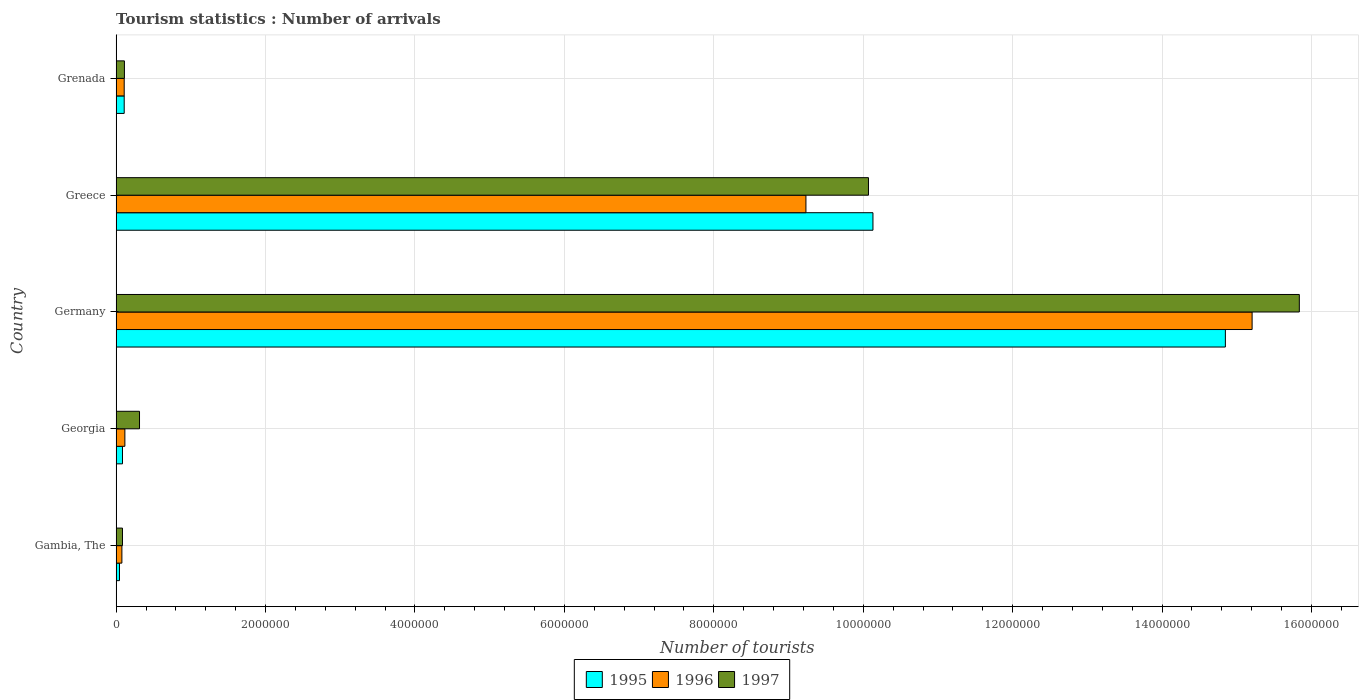How many different coloured bars are there?
Keep it short and to the point. 3. How many groups of bars are there?
Ensure brevity in your answer.  5. Are the number of bars per tick equal to the number of legend labels?
Give a very brief answer. Yes. Are the number of bars on each tick of the Y-axis equal?
Your answer should be very brief. Yes. How many bars are there on the 3rd tick from the bottom?
Provide a succinct answer. 3. What is the label of the 5th group of bars from the top?
Your answer should be compact. Gambia, The. What is the number of tourist arrivals in 1996 in Gambia, The?
Your response must be concise. 7.70e+04. Across all countries, what is the maximum number of tourist arrivals in 1996?
Offer a very short reply. 1.52e+07. Across all countries, what is the minimum number of tourist arrivals in 1995?
Your response must be concise. 4.50e+04. In which country was the number of tourist arrivals in 1996 minimum?
Your answer should be very brief. Gambia, The. What is the total number of tourist arrivals in 1996 in the graph?
Keep it short and to the point. 2.47e+07. What is the difference between the number of tourist arrivals in 1996 in Greece and that in Grenada?
Give a very brief answer. 9.12e+06. What is the difference between the number of tourist arrivals in 1995 in Greece and the number of tourist arrivals in 1996 in Georgia?
Your answer should be compact. 1.00e+07. What is the average number of tourist arrivals in 1997 per country?
Your response must be concise. 5.28e+06. What is the difference between the number of tourist arrivals in 1995 and number of tourist arrivals in 1996 in Georgia?
Keep it short and to the point. -3.20e+04. What is the ratio of the number of tourist arrivals in 1997 in Germany to that in Greece?
Provide a short and direct response. 1.57. What is the difference between the highest and the second highest number of tourist arrivals in 1996?
Your answer should be very brief. 5.97e+06. What is the difference between the highest and the lowest number of tourist arrivals in 1997?
Your answer should be very brief. 1.58e+07. Is the sum of the number of tourist arrivals in 1997 in Germany and Greece greater than the maximum number of tourist arrivals in 1996 across all countries?
Provide a succinct answer. Yes. What does the 1st bar from the top in Georgia represents?
Give a very brief answer. 1997. What does the 3rd bar from the bottom in Greece represents?
Offer a very short reply. 1997. Is it the case that in every country, the sum of the number of tourist arrivals in 1997 and number of tourist arrivals in 1996 is greater than the number of tourist arrivals in 1995?
Your response must be concise. Yes. How many countries are there in the graph?
Offer a terse response. 5. What is the difference between two consecutive major ticks on the X-axis?
Make the answer very short. 2.00e+06. Are the values on the major ticks of X-axis written in scientific E-notation?
Your answer should be very brief. No. Does the graph contain any zero values?
Give a very brief answer. No. Where does the legend appear in the graph?
Keep it short and to the point. Bottom center. What is the title of the graph?
Your response must be concise. Tourism statistics : Number of arrivals. Does "2000" appear as one of the legend labels in the graph?
Your response must be concise. No. What is the label or title of the X-axis?
Provide a short and direct response. Number of tourists. What is the label or title of the Y-axis?
Your answer should be very brief. Country. What is the Number of tourists in 1995 in Gambia, The?
Your response must be concise. 4.50e+04. What is the Number of tourists of 1996 in Gambia, The?
Offer a very short reply. 7.70e+04. What is the Number of tourists in 1997 in Gambia, The?
Provide a short and direct response. 8.50e+04. What is the Number of tourists in 1995 in Georgia?
Your response must be concise. 8.50e+04. What is the Number of tourists in 1996 in Georgia?
Give a very brief answer. 1.17e+05. What is the Number of tourists in 1997 in Georgia?
Your answer should be compact. 3.13e+05. What is the Number of tourists of 1995 in Germany?
Your answer should be compact. 1.48e+07. What is the Number of tourists of 1996 in Germany?
Make the answer very short. 1.52e+07. What is the Number of tourists in 1997 in Germany?
Provide a succinct answer. 1.58e+07. What is the Number of tourists in 1995 in Greece?
Give a very brief answer. 1.01e+07. What is the Number of tourists of 1996 in Greece?
Make the answer very short. 9.23e+06. What is the Number of tourists of 1997 in Greece?
Provide a short and direct response. 1.01e+07. What is the Number of tourists of 1995 in Grenada?
Make the answer very short. 1.08e+05. What is the Number of tourists of 1996 in Grenada?
Ensure brevity in your answer.  1.08e+05. What is the Number of tourists in 1997 in Grenada?
Keep it short and to the point. 1.11e+05. Across all countries, what is the maximum Number of tourists in 1995?
Your response must be concise. 1.48e+07. Across all countries, what is the maximum Number of tourists in 1996?
Offer a terse response. 1.52e+07. Across all countries, what is the maximum Number of tourists of 1997?
Your answer should be compact. 1.58e+07. Across all countries, what is the minimum Number of tourists in 1995?
Your answer should be compact. 4.50e+04. Across all countries, what is the minimum Number of tourists in 1996?
Give a very brief answer. 7.70e+04. Across all countries, what is the minimum Number of tourists in 1997?
Keep it short and to the point. 8.50e+04. What is the total Number of tourists of 1995 in the graph?
Offer a very short reply. 2.52e+07. What is the total Number of tourists in 1996 in the graph?
Provide a short and direct response. 2.47e+07. What is the total Number of tourists in 1997 in the graph?
Your answer should be compact. 2.64e+07. What is the difference between the Number of tourists in 1995 in Gambia, The and that in Georgia?
Provide a succinct answer. -4.00e+04. What is the difference between the Number of tourists of 1997 in Gambia, The and that in Georgia?
Offer a terse response. -2.28e+05. What is the difference between the Number of tourists in 1995 in Gambia, The and that in Germany?
Provide a succinct answer. -1.48e+07. What is the difference between the Number of tourists of 1996 in Gambia, The and that in Germany?
Ensure brevity in your answer.  -1.51e+07. What is the difference between the Number of tourists in 1997 in Gambia, The and that in Germany?
Your answer should be compact. -1.58e+07. What is the difference between the Number of tourists of 1995 in Gambia, The and that in Greece?
Your answer should be compact. -1.01e+07. What is the difference between the Number of tourists of 1996 in Gambia, The and that in Greece?
Make the answer very short. -9.16e+06. What is the difference between the Number of tourists of 1997 in Gambia, The and that in Greece?
Provide a short and direct response. -9.98e+06. What is the difference between the Number of tourists in 1995 in Gambia, The and that in Grenada?
Your answer should be very brief. -6.30e+04. What is the difference between the Number of tourists in 1996 in Gambia, The and that in Grenada?
Provide a short and direct response. -3.10e+04. What is the difference between the Number of tourists in 1997 in Gambia, The and that in Grenada?
Ensure brevity in your answer.  -2.60e+04. What is the difference between the Number of tourists in 1995 in Georgia and that in Germany?
Offer a very short reply. -1.48e+07. What is the difference between the Number of tourists in 1996 in Georgia and that in Germany?
Your answer should be compact. -1.51e+07. What is the difference between the Number of tourists of 1997 in Georgia and that in Germany?
Offer a terse response. -1.55e+07. What is the difference between the Number of tourists of 1995 in Georgia and that in Greece?
Keep it short and to the point. -1.00e+07. What is the difference between the Number of tourists of 1996 in Georgia and that in Greece?
Offer a very short reply. -9.12e+06. What is the difference between the Number of tourists in 1997 in Georgia and that in Greece?
Your answer should be compact. -9.76e+06. What is the difference between the Number of tourists of 1995 in Georgia and that in Grenada?
Make the answer very short. -2.30e+04. What is the difference between the Number of tourists in 1996 in Georgia and that in Grenada?
Offer a terse response. 9000. What is the difference between the Number of tourists of 1997 in Georgia and that in Grenada?
Provide a short and direct response. 2.02e+05. What is the difference between the Number of tourists in 1995 in Germany and that in Greece?
Your answer should be compact. 4.72e+06. What is the difference between the Number of tourists in 1996 in Germany and that in Greece?
Your answer should be compact. 5.97e+06. What is the difference between the Number of tourists of 1997 in Germany and that in Greece?
Ensure brevity in your answer.  5.77e+06. What is the difference between the Number of tourists of 1995 in Germany and that in Grenada?
Give a very brief answer. 1.47e+07. What is the difference between the Number of tourists in 1996 in Germany and that in Grenada?
Provide a short and direct response. 1.51e+07. What is the difference between the Number of tourists in 1997 in Germany and that in Grenada?
Offer a very short reply. 1.57e+07. What is the difference between the Number of tourists in 1995 in Greece and that in Grenada?
Your answer should be very brief. 1.00e+07. What is the difference between the Number of tourists in 1996 in Greece and that in Grenada?
Provide a succinct answer. 9.12e+06. What is the difference between the Number of tourists in 1997 in Greece and that in Grenada?
Offer a terse response. 9.96e+06. What is the difference between the Number of tourists of 1995 in Gambia, The and the Number of tourists of 1996 in Georgia?
Offer a very short reply. -7.20e+04. What is the difference between the Number of tourists in 1995 in Gambia, The and the Number of tourists in 1997 in Georgia?
Give a very brief answer. -2.68e+05. What is the difference between the Number of tourists in 1996 in Gambia, The and the Number of tourists in 1997 in Georgia?
Keep it short and to the point. -2.36e+05. What is the difference between the Number of tourists of 1995 in Gambia, The and the Number of tourists of 1996 in Germany?
Provide a short and direct response. -1.52e+07. What is the difference between the Number of tourists in 1995 in Gambia, The and the Number of tourists in 1997 in Germany?
Give a very brief answer. -1.58e+07. What is the difference between the Number of tourists in 1996 in Gambia, The and the Number of tourists in 1997 in Germany?
Offer a very short reply. -1.58e+07. What is the difference between the Number of tourists of 1995 in Gambia, The and the Number of tourists of 1996 in Greece?
Provide a short and direct response. -9.19e+06. What is the difference between the Number of tourists in 1995 in Gambia, The and the Number of tourists in 1997 in Greece?
Your response must be concise. -1.00e+07. What is the difference between the Number of tourists of 1996 in Gambia, The and the Number of tourists of 1997 in Greece?
Your answer should be very brief. -9.99e+06. What is the difference between the Number of tourists of 1995 in Gambia, The and the Number of tourists of 1996 in Grenada?
Ensure brevity in your answer.  -6.30e+04. What is the difference between the Number of tourists in 1995 in Gambia, The and the Number of tourists in 1997 in Grenada?
Ensure brevity in your answer.  -6.60e+04. What is the difference between the Number of tourists of 1996 in Gambia, The and the Number of tourists of 1997 in Grenada?
Offer a terse response. -3.40e+04. What is the difference between the Number of tourists in 1995 in Georgia and the Number of tourists in 1996 in Germany?
Provide a short and direct response. -1.51e+07. What is the difference between the Number of tourists of 1995 in Georgia and the Number of tourists of 1997 in Germany?
Offer a very short reply. -1.58e+07. What is the difference between the Number of tourists of 1996 in Georgia and the Number of tourists of 1997 in Germany?
Give a very brief answer. -1.57e+07. What is the difference between the Number of tourists in 1995 in Georgia and the Number of tourists in 1996 in Greece?
Your answer should be compact. -9.15e+06. What is the difference between the Number of tourists in 1995 in Georgia and the Number of tourists in 1997 in Greece?
Give a very brief answer. -9.98e+06. What is the difference between the Number of tourists of 1996 in Georgia and the Number of tourists of 1997 in Greece?
Make the answer very short. -9.95e+06. What is the difference between the Number of tourists of 1995 in Georgia and the Number of tourists of 1996 in Grenada?
Offer a terse response. -2.30e+04. What is the difference between the Number of tourists in 1995 in Georgia and the Number of tourists in 1997 in Grenada?
Give a very brief answer. -2.60e+04. What is the difference between the Number of tourists in 1996 in Georgia and the Number of tourists in 1997 in Grenada?
Provide a succinct answer. 6000. What is the difference between the Number of tourists in 1995 in Germany and the Number of tourists in 1996 in Greece?
Offer a terse response. 5.61e+06. What is the difference between the Number of tourists of 1995 in Germany and the Number of tourists of 1997 in Greece?
Keep it short and to the point. 4.78e+06. What is the difference between the Number of tourists of 1996 in Germany and the Number of tourists of 1997 in Greece?
Your answer should be very brief. 5.14e+06. What is the difference between the Number of tourists in 1995 in Germany and the Number of tourists in 1996 in Grenada?
Your answer should be compact. 1.47e+07. What is the difference between the Number of tourists in 1995 in Germany and the Number of tourists in 1997 in Grenada?
Make the answer very short. 1.47e+07. What is the difference between the Number of tourists in 1996 in Germany and the Number of tourists in 1997 in Grenada?
Provide a short and direct response. 1.51e+07. What is the difference between the Number of tourists of 1995 in Greece and the Number of tourists of 1996 in Grenada?
Give a very brief answer. 1.00e+07. What is the difference between the Number of tourists of 1995 in Greece and the Number of tourists of 1997 in Grenada?
Your answer should be compact. 1.00e+07. What is the difference between the Number of tourists in 1996 in Greece and the Number of tourists in 1997 in Grenada?
Make the answer very short. 9.12e+06. What is the average Number of tourists of 1995 per country?
Your response must be concise. 5.04e+06. What is the average Number of tourists of 1996 per country?
Your answer should be compact. 4.95e+06. What is the average Number of tourists of 1997 per country?
Make the answer very short. 5.28e+06. What is the difference between the Number of tourists in 1995 and Number of tourists in 1996 in Gambia, The?
Your answer should be very brief. -3.20e+04. What is the difference between the Number of tourists in 1996 and Number of tourists in 1997 in Gambia, The?
Your answer should be very brief. -8000. What is the difference between the Number of tourists in 1995 and Number of tourists in 1996 in Georgia?
Your response must be concise. -3.20e+04. What is the difference between the Number of tourists of 1995 and Number of tourists of 1997 in Georgia?
Offer a very short reply. -2.28e+05. What is the difference between the Number of tourists in 1996 and Number of tourists in 1997 in Georgia?
Give a very brief answer. -1.96e+05. What is the difference between the Number of tourists of 1995 and Number of tourists of 1996 in Germany?
Keep it short and to the point. -3.58e+05. What is the difference between the Number of tourists of 1995 and Number of tourists of 1997 in Germany?
Keep it short and to the point. -9.90e+05. What is the difference between the Number of tourists of 1996 and Number of tourists of 1997 in Germany?
Make the answer very short. -6.32e+05. What is the difference between the Number of tourists in 1995 and Number of tourists in 1996 in Greece?
Your response must be concise. 8.97e+05. What is the difference between the Number of tourists in 1995 and Number of tourists in 1997 in Greece?
Give a very brief answer. 6.00e+04. What is the difference between the Number of tourists in 1996 and Number of tourists in 1997 in Greece?
Your answer should be compact. -8.37e+05. What is the difference between the Number of tourists of 1995 and Number of tourists of 1997 in Grenada?
Provide a short and direct response. -3000. What is the difference between the Number of tourists of 1996 and Number of tourists of 1997 in Grenada?
Offer a terse response. -3000. What is the ratio of the Number of tourists of 1995 in Gambia, The to that in Georgia?
Offer a terse response. 0.53. What is the ratio of the Number of tourists in 1996 in Gambia, The to that in Georgia?
Give a very brief answer. 0.66. What is the ratio of the Number of tourists of 1997 in Gambia, The to that in Georgia?
Your response must be concise. 0.27. What is the ratio of the Number of tourists of 1995 in Gambia, The to that in Germany?
Your response must be concise. 0. What is the ratio of the Number of tourists of 1996 in Gambia, The to that in Germany?
Make the answer very short. 0.01. What is the ratio of the Number of tourists of 1997 in Gambia, The to that in Germany?
Provide a short and direct response. 0.01. What is the ratio of the Number of tourists in 1995 in Gambia, The to that in Greece?
Your answer should be very brief. 0. What is the ratio of the Number of tourists in 1996 in Gambia, The to that in Greece?
Make the answer very short. 0.01. What is the ratio of the Number of tourists in 1997 in Gambia, The to that in Greece?
Provide a succinct answer. 0.01. What is the ratio of the Number of tourists of 1995 in Gambia, The to that in Grenada?
Offer a terse response. 0.42. What is the ratio of the Number of tourists of 1996 in Gambia, The to that in Grenada?
Offer a very short reply. 0.71. What is the ratio of the Number of tourists of 1997 in Gambia, The to that in Grenada?
Make the answer very short. 0.77. What is the ratio of the Number of tourists in 1995 in Georgia to that in Germany?
Offer a terse response. 0.01. What is the ratio of the Number of tourists in 1996 in Georgia to that in Germany?
Provide a short and direct response. 0.01. What is the ratio of the Number of tourists of 1997 in Georgia to that in Germany?
Your answer should be compact. 0.02. What is the ratio of the Number of tourists in 1995 in Georgia to that in Greece?
Your response must be concise. 0.01. What is the ratio of the Number of tourists of 1996 in Georgia to that in Greece?
Your answer should be very brief. 0.01. What is the ratio of the Number of tourists of 1997 in Georgia to that in Greece?
Your response must be concise. 0.03. What is the ratio of the Number of tourists of 1995 in Georgia to that in Grenada?
Your answer should be very brief. 0.79. What is the ratio of the Number of tourists of 1996 in Georgia to that in Grenada?
Provide a succinct answer. 1.08. What is the ratio of the Number of tourists in 1997 in Georgia to that in Grenada?
Your answer should be very brief. 2.82. What is the ratio of the Number of tourists of 1995 in Germany to that in Greece?
Give a very brief answer. 1.47. What is the ratio of the Number of tourists in 1996 in Germany to that in Greece?
Keep it short and to the point. 1.65. What is the ratio of the Number of tourists of 1997 in Germany to that in Greece?
Give a very brief answer. 1.57. What is the ratio of the Number of tourists of 1995 in Germany to that in Grenada?
Give a very brief answer. 137.47. What is the ratio of the Number of tourists of 1996 in Germany to that in Grenada?
Offer a terse response. 140.79. What is the ratio of the Number of tourists in 1997 in Germany to that in Grenada?
Ensure brevity in your answer.  142.68. What is the ratio of the Number of tourists of 1995 in Greece to that in Grenada?
Your answer should be very brief. 93.8. What is the ratio of the Number of tourists in 1996 in Greece to that in Grenada?
Give a very brief answer. 85.49. What is the ratio of the Number of tourists of 1997 in Greece to that in Grenada?
Offer a very short reply. 90.72. What is the difference between the highest and the second highest Number of tourists in 1995?
Offer a terse response. 4.72e+06. What is the difference between the highest and the second highest Number of tourists of 1996?
Give a very brief answer. 5.97e+06. What is the difference between the highest and the second highest Number of tourists of 1997?
Keep it short and to the point. 5.77e+06. What is the difference between the highest and the lowest Number of tourists of 1995?
Offer a terse response. 1.48e+07. What is the difference between the highest and the lowest Number of tourists of 1996?
Provide a short and direct response. 1.51e+07. What is the difference between the highest and the lowest Number of tourists in 1997?
Make the answer very short. 1.58e+07. 